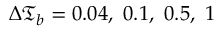Convert formula to latex. <formula><loc_0><loc_0><loc_500><loc_500>\Delta \mathfrak { T } _ { b } = 0 . 0 4 , \ 0 . 1 , \ 0 . 5 , \ 1</formula> 